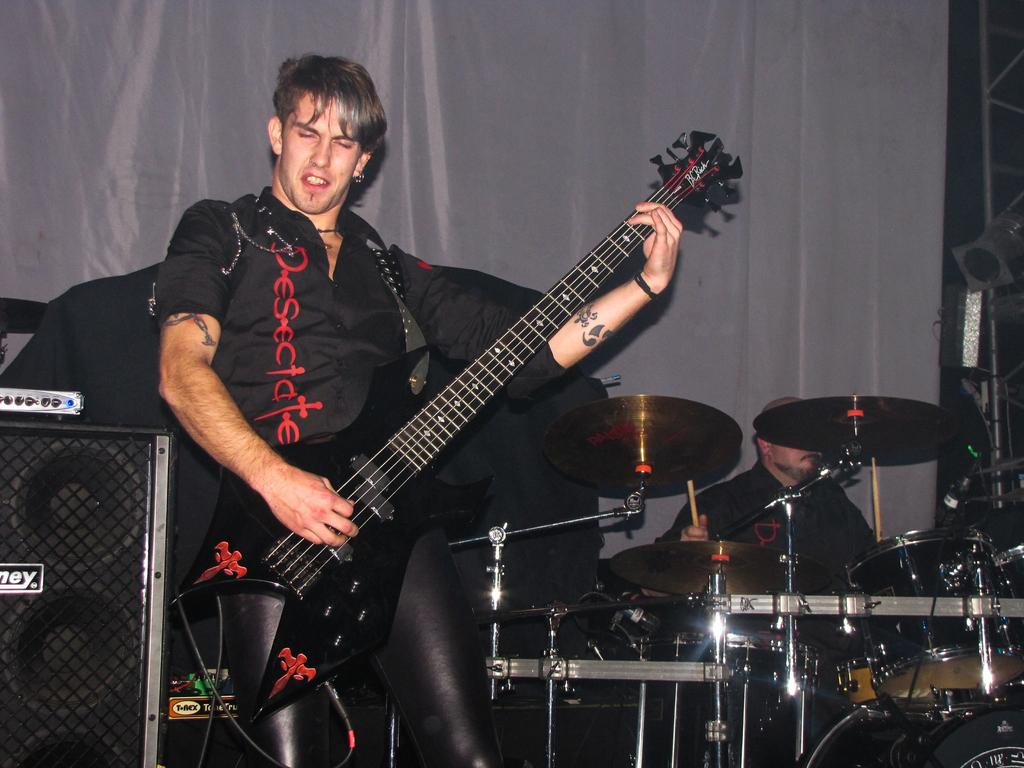What is the man in the image doing? The man is playing a guitar in the image. Are there any other musicians in the image? Yes, there is another man playing drums in the image. What is used to amplify the sound in the image? There is a speaker in the image. What can be seen in the background of the image? There is a cloth visible in the background of the image. What type of trouble is the man sitting on the sofa experiencing in the image? There is no man sitting on a sofa in the image, and no trouble is depicted. What is the value of the guitar in the image? The value of the guitar cannot be determined from the image alone. 